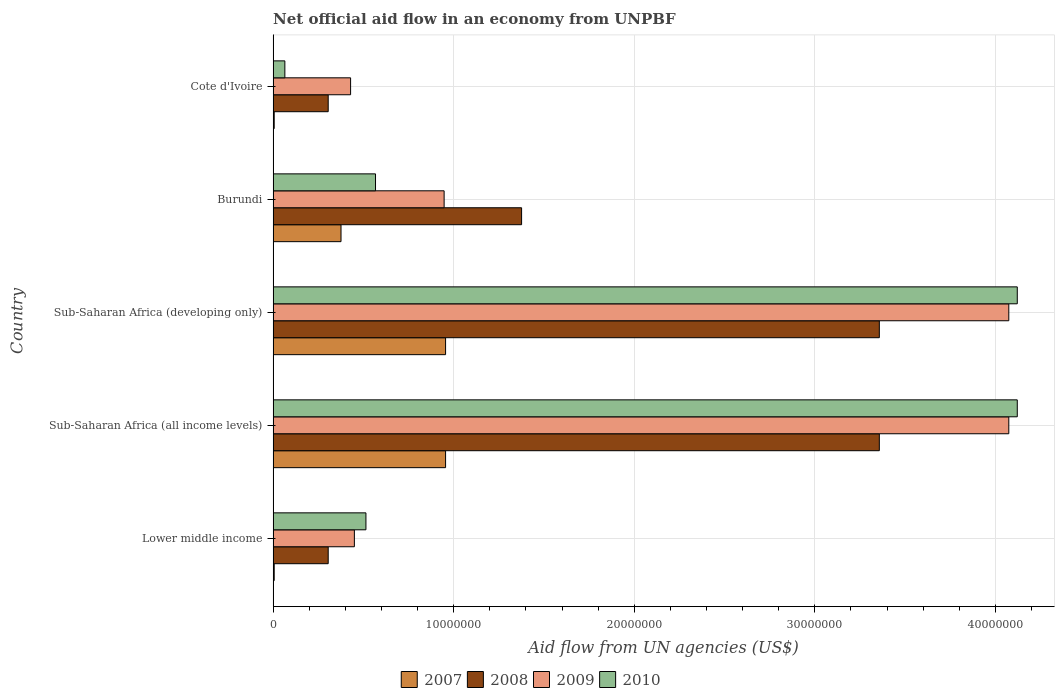How many different coloured bars are there?
Offer a very short reply. 4. How many bars are there on the 2nd tick from the bottom?
Keep it short and to the point. 4. What is the label of the 5th group of bars from the top?
Give a very brief answer. Lower middle income. What is the net official aid flow in 2009 in Sub-Saharan Africa (all income levels)?
Provide a succinct answer. 4.07e+07. Across all countries, what is the maximum net official aid flow in 2009?
Offer a terse response. 4.07e+07. Across all countries, what is the minimum net official aid flow in 2008?
Give a very brief answer. 3.05e+06. In which country was the net official aid flow in 2008 maximum?
Keep it short and to the point. Sub-Saharan Africa (all income levels). In which country was the net official aid flow in 2009 minimum?
Ensure brevity in your answer.  Cote d'Ivoire. What is the total net official aid flow in 2007 in the graph?
Your answer should be very brief. 2.30e+07. What is the difference between the net official aid flow in 2007 in Burundi and that in Cote d'Ivoire?
Make the answer very short. 3.70e+06. What is the difference between the net official aid flow in 2009 in Burundi and the net official aid flow in 2008 in Sub-Saharan Africa (developing only)?
Ensure brevity in your answer.  -2.41e+07. What is the average net official aid flow in 2010 per country?
Give a very brief answer. 1.88e+07. What is the difference between the net official aid flow in 2007 and net official aid flow in 2010 in Cote d'Ivoire?
Provide a succinct answer. -5.90e+05. In how many countries, is the net official aid flow in 2010 greater than 24000000 US$?
Make the answer very short. 2. What is the ratio of the net official aid flow in 2009 in Lower middle income to that in Sub-Saharan Africa (all income levels)?
Ensure brevity in your answer.  0.11. Is the net official aid flow in 2008 in Burundi less than that in Sub-Saharan Africa (all income levels)?
Offer a very short reply. Yes. Is the difference between the net official aid flow in 2007 in Burundi and Lower middle income greater than the difference between the net official aid flow in 2010 in Burundi and Lower middle income?
Your response must be concise. Yes. What is the difference between the highest and the second highest net official aid flow in 2010?
Make the answer very short. 0. What is the difference between the highest and the lowest net official aid flow in 2010?
Your response must be concise. 4.06e+07. Is the sum of the net official aid flow in 2009 in Burundi and Sub-Saharan Africa (developing only) greater than the maximum net official aid flow in 2008 across all countries?
Give a very brief answer. Yes. Is it the case that in every country, the sum of the net official aid flow in 2007 and net official aid flow in 2010 is greater than the net official aid flow in 2009?
Your response must be concise. No. How many bars are there?
Offer a terse response. 20. Are all the bars in the graph horizontal?
Your answer should be very brief. Yes. Are the values on the major ticks of X-axis written in scientific E-notation?
Provide a short and direct response. No. Does the graph contain any zero values?
Provide a succinct answer. No. Does the graph contain grids?
Your response must be concise. Yes. Where does the legend appear in the graph?
Your answer should be compact. Bottom center. How many legend labels are there?
Offer a very short reply. 4. How are the legend labels stacked?
Make the answer very short. Horizontal. What is the title of the graph?
Your response must be concise. Net official aid flow in an economy from UNPBF. Does "1976" appear as one of the legend labels in the graph?
Offer a very short reply. No. What is the label or title of the X-axis?
Ensure brevity in your answer.  Aid flow from UN agencies (US$). What is the Aid flow from UN agencies (US$) of 2007 in Lower middle income?
Ensure brevity in your answer.  6.00e+04. What is the Aid flow from UN agencies (US$) of 2008 in Lower middle income?
Give a very brief answer. 3.05e+06. What is the Aid flow from UN agencies (US$) in 2009 in Lower middle income?
Your answer should be very brief. 4.50e+06. What is the Aid flow from UN agencies (US$) in 2010 in Lower middle income?
Your answer should be compact. 5.14e+06. What is the Aid flow from UN agencies (US$) of 2007 in Sub-Saharan Africa (all income levels)?
Your answer should be compact. 9.55e+06. What is the Aid flow from UN agencies (US$) of 2008 in Sub-Saharan Africa (all income levels)?
Provide a succinct answer. 3.36e+07. What is the Aid flow from UN agencies (US$) of 2009 in Sub-Saharan Africa (all income levels)?
Keep it short and to the point. 4.07e+07. What is the Aid flow from UN agencies (US$) in 2010 in Sub-Saharan Africa (all income levels)?
Provide a succinct answer. 4.12e+07. What is the Aid flow from UN agencies (US$) in 2007 in Sub-Saharan Africa (developing only)?
Your answer should be compact. 9.55e+06. What is the Aid flow from UN agencies (US$) of 2008 in Sub-Saharan Africa (developing only)?
Your answer should be very brief. 3.36e+07. What is the Aid flow from UN agencies (US$) of 2009 in Sub-Saharan Africa (developing only)?
Provide a succinct answer. 4.07e+07. What is the Aid flow from UN agencies (US$) in 2010 in Sub-Saharan Africa (developing only)?
Your response must be concise. 4.12e+07. What is the Aid flow from UN agencies (US$) in 2007 in Burundi?
Your response must be concise. 3.76e+06. What is the Aid flow from UN agencies (US$) of 2008 in Burundi?
Keep it short and to the point. 1.38e+07. What is the Aid flow from UN agencies (US$) of 2009 in Burundi?
Your answer should be compact. 9.47e+06. What is the Aid flow from UN agencies (US$) of 2010 in Burundi?
Give a very brief answer. 5.67e+06. What is the Aid flow from UN agencies (US$) in 2007 in Cote d'Ivoire?
Make the answer very short. 6.00e+04. What is the Aid flow from UN agencies (US$) in 2008 in Cote d'Ivoire?
Offer a terse response. 3.05e+06. What is the Aid flow from UN agencies (US$) of 2009 in Cote d'Ivoire?
Ensure brevity in your answer.  4.29e+06. What is the Aid flow from UN agencies (US$) in 2010 in Cote d'Ivoire?
Make the answer very short. 6.50e+05. Across all countries, what is the maximum Aid flow from UN agencies (US$) in 2007?
Offer a very short reply. 9.55e+06. Across all countries, what is the maximum Aid flow from UN agencies (US$) of 2008?
Offer a terse response. 3.36e+07. Across all countries, what is the maximum Aid flow from UN agencies (US$) of 2009?
Ensure brevity in your answer.  4.07e+07. Across all countries, what is the maximum Aid flow from UN agencies (US$) of 2010?
Provide a short and direct response. 4.12e+07. Across all countries, what is the minimum Aid flow from UN agencies (US$) in 2008?
Your response must be concise. 3.05e+06. Across all countries, what is the minimum Aid flow from UN agencies (US$) in 2009?
Provide a succinct answer. 4.29e+06. Across all countries, what is the minimum Aid flow from UN agencies (US$) in 2010?
Your response must be concise. 6.50e+05. What is the total Aid flow from UN agencies (US$) in 2007 in the graph?
Provide a succinct answer. 2.30e+07. What is the total Aid flow from UN agencies (US$) of 2008 in the graph?
Your response must be concise. 8.70e+07. What is the total Aid flow from UN agencies (US$) of 2009 in the graph?
Provide a succinct answer. 9.97e+07. What is the total Aid flow from UN agencies (US$) of 2010 in the graph?
Your answer should be very brief. 9.39e+07. What is the difference between the Aid flow from UN agencies (US$) in 2007 in Lower middle income and that in Sub-Saharan Africa (all income levels)?
Your answer should be very brief. -9.49e+06. What is the difference between the Aid flow from UN agencies (US$) in 2008 in Lower middle income and that in Sub-Saharan Africa (all income levels)?
Give a very brief answer. -3.05e+07. What is the difference between the Aid flow from UN agencies (US$) of 2009 in Lower middle income and that in Sub-Saharan Africa (all income levels)?
Your answer should be very brief. -3.62e+07. What is the difference between the Aid flow from UN agencies (US$) of 2010 in Lower middle income and that in Sub-Saharan Africa (all income levels)?
Make the answer very short. -3.61e+07. What is the difference between the Aid flow from UN agencies (US$) of 2007 in Lower middle income and that in Sub-Saharan Africa (developing only)?
Make the answer very short. -9.49e+06. What is the difference between the Aid flow from UN agencies (US$) of 2008 in Lower middle income and that in Sub-Saharan Africa (developing only)?
Make the answer very short. -3.05e+07. What is the difference between the Aid flow from UN agencies (US$) of 2009 in Lower middle income and that in Sub-Saharan Africa (developing only)?
Offer a very short reply. -3.62e+07. What is the difference between the Aid flow from UN agencies (US$) in 2010 in Lower middle income and that in Sub-Saharan Africa (developing only)?
Make the answer very short. -3.61e+07. What is the difference between the Aid flow from UN agencies (US$) of 2007 in Lower middle income and that in Burundi?
Offer a terse response. -3.70e+06. What is the difference between the Aid flow from UN agencies (US$) of 2008 in Lower middle income and that in Burundi?
Ensure brevity in your answer.  -1.07e+07. What is the difference between the Aid flow from UN agencies (US$) in 2009 in Lower middle income and that in Burundi?
Your answer should be very brief. -4.97e+06. What is the difference between the Aid flow from UN agencies (US$) of 2010 in Lower middle income and that in Burundi?
Offer a terse response. -5.30e+05. What is the difference between the Aid flow from UN agencies (US$) of 2007 in Lower middle income and that in Cote d'Ivoire?
Your answer should be very brief. 0. What is the difference between the Aid flow from UN agencies (US$) of 2008 in Lower middle income and that in Cote d'Ivoire?
Provide a short and direct response. 0. What is the difference between the Aid flow from UN agencies (US$) in 2010 in Lower middle income and that in Cote d'Ivoire?
Give a very brief answer. 4.49e+06. What is the difference between the Aid flow from UN agencies (US$) in 2008 in Sub-Saharan Africa (all income levels) and that in Sub-Saharan Africa (developing only)?
Your answer should be compact. 0. What is the difference between the Aid flow from UN agencies (US$) in 2010 in Sub-Saharan Africa (all income levels) and that in Sub-Saharan Africa (developing only)?
Your answer should be very brief. 0. What is the difference between the Aid flow from UN agencies (US$) of 2007 in Sub-Saharan Africa (all income levels) and that in Burundi?
Give a very brief answer. 5.79e+06. What is the difference between the Aid flow from UN agencies (US$) in 2008 in Sub-Saharan Africa (all income levels) and that in Burundi?
Give a very brief answer. 1.98e+07. What is the difference between the Aid flow from UN agencies (US$) of 2009 in Sub-Saharan Africa (all income levels) and that in Burundi?
Your answer should be compact. 3.13e+07. What is the difference between the Aid flow from UN agencies (US$) of 2010 in Sub-Saharan Africa (all income levels) and that in Burundi?
Provide a succinct answer. 3.55e+07. What is the difference between the Aid flow from UN agencies (US$) of 2007 in Sub-Saharan Africa (all income levels) and that in Cote d'Ivoire?
Offer a very short reply. 9.49e+06. What is the difference between the Aid flow from UN agencies (US$) of 2008 in Sub-Saharan Africa (all income levels) and that in Cote d'Ivoire?
Make the answer very short. 3.05e+07. What is the difference between the Aid flow from UN agencies (US$) of 2009 in Sub-Saharan Africa (all income levels) and that in Cote d'Ivoire?
Your response must be concise. 3.64e+07. What is the difference between the Aid flow from UN agencies (US$) of 2010 in Sub-Saharan Africa (all income levels) and that in Cote d'Ivoire?
Provide a succinct answer. 4.06e+07. What is the difference between the Aid flow from UN agencies (US$) of 2007 in Sub-Saharan Africa (developing only) and that in Burundi?
Ensure brevity in your answer.  5.79e+06. What is the difference between the Aid flow from UN agencies (US$) in 2008 in Sub-Saharan Africa (developing only) and that in Burundi?
Make the answer very short. 1.98e+07. What is the difference between the Aid flow from UN agencies (US$) of 2009 in Sub-Saharan Africa (developing only) and that in Burundi?
Provide a short and direct response. 3.13e+07. What is the difference between the Aid flow from UN agencies (US$) of 2010 in Sub-Saharan Africa (developing only) and that in Burundi?
Your answer should be very brief. 3.55e+07. What is the difference between the Aid flow from UN agencies (US$) of 2007 in Sub-Saharan Africa (developing only) and that in Cote d'Ivoire?
Keep it short and to the point. 9.49e+06. What is the difference between the Aid flow from UN agencies (US$) of 2008 in Sub-Saharan Africa (developing only) and that in Cote d'Ivoire?
Offer a very short reply. 3.05e+07. What is the difference between the Aid flow from UN agencies (US$) of 2009 in Sub-Saharan Africa (developing only) and that in Cote d'Ivoire?
Offer a very short reply. 3.64e+07. What is the difference between the Aid flow from UN agencies (US$) of 2010 in Sub-Saharan Africa (developing only) and that in Cote d'Ivoire?
Your answer should be very brief. 4.06e+07. What is the difference between the Aid flow from UN agencies (US$) in 2007 in Burundi and that in Cote d'Ivoire?
Your response must be concise. 3.70e+06. What is the difference between the Aid flow from UN agencies (US$) of 2008 in Burundi and that in Cote d'Ivoire?
Provide a succinct answer. 1.07e+07. What is the difference between the Aid flow from UN agencies (US$) of 2009 in Burundi and that in Cote d'Ivoire?
Keep it short and to the point. 5.18e+06. What is the difference between the Aid flow from UN agencies (US$) in 2010 in Burundi and that in Cote d'Ivoire?
Keep it short and to the point. 5.02e+06. What is the difference between the Aid flow from UN agencies (US$) of 2007 in Lower middle income and the Aid flow from UN agencies (US$) of 2008 in Sub-Saharan Africa (all income levels)?
Provide a succinct answer. -3.35e+07. What is the difference between the Aid flow from UN agencies (US$) of 2007 in Lower middle income and the Aid flow from UN agencies (US$) of 2009 in Sub-Saharan Africa (all income levels)?
Your response must be concise. -4.07e+07. What is the difference between the Aid flow from UN agencies (US$) in 2007 in Lower middle income and the Aid flow from UN agencies (US$) in 2010 in Sub-Saharan Africa (all income levels)?
Give a very brief answer. -4.12e+07. What is the difference between the Aid flow from UN agencies (US$) in 2008 in Lower middle income and the Aid flow from UN agencies (US$) in 2009 in Sub-Saharan Africa (all income levels)?
Provide a succinct answer. -3.77e+07. What is the difference between the Aid flow from UN agencies (US$) in 2008 in Lower middle income and the Aid flow from UN agencies (US$) in 2010 in Sub-Saharan Africa (all income levels)?
Make the answer very short. -3.82e+07. What is the difference between the Aid flow from UN agencies (US$) in 2009 in Lower middle income and the Aid flow from UN agencies (US$) in 2010 in Sub-Saharan Africa (all income levels)?
Your response must be concise. -3.67e+07. What is the difference between the Aid flow from UN agencies (US$) of 2007 in Lower middle income and the Aid flow from UN agencies (US$) of 2008 in Sub-Saharan Africa (developing only)?
Provide a succinct answer. -3.35e+07. What is the difference between the Aid flow from UN agencies (US$) of 2007 in Lower middle income and the Aid flow from UN agencies (US$) of 2009 in Sub-Saharan Africa (developing only)?
Keep it short and to the point. -4.07e+07. What is the difference between the Aid flow from UN agencies (US$) of 2007 in Lower middle income and the Aid flow from UN agencies (US$) of 2010 in Sub-Saharan Africa (developing only)?
Offer a terse response. -4.12e+07. What is the difference between the Aid flow from UN agencies (US$) in 2008 in Lower middle income and the Aid flow from UN agencies (US$) in 2009 in Sub-Saharan Africa (developing only)?
Your answer should be very brief. -3.77e+07. What is the difference between the Aid flow from UN agencies (US$) in 2008 in Lower middle income and the Aid flow from UN agencies (US$) in 2010 in Sub-Saharan Africa (developing only)?
Make the answer very short. -3.82e+07. What is the difference between the Aid flow from UN agencies (US$) in 2009 in Lower middle income and the Aid flow from UN agencies (US$) in 2010 in Sub-Saharan Africa (developing only)?
Your response must be concise. -3.67e+07. What is the difference between the Aid flow from UN agencies (US$) in 2007 in Lower middle income and the Aid flow from UN agencies (US$) in 2008 in Burundi?
Provide a succinct answer. -1.37e+07. What is the difference between the Aid flow from UN agencies (US$) in 2007 in Lower middle income and the Aid flow from UN agencies (US$) in 2009 in Burundi?
Your response must be concise. -9.41e+06. What is the difference between the Aid flow from UN agencies (US$) in 2007 in Lower middle income and the Aid flow from UN agencies (US$) in 2010 in Burundi?
Your response must be concise. -5.61e+06. What is the difference between the Aid flow from UN agencies (US$) of 2008 in Lower middle income and the Aid flow from UN agencies (US$) of 2009 in Burundi?
Offer a terse response. -6.42e+06. What is the difference between the Aid flow from UN agencies (US$) in 2008 in Lower middle income and the Aid flow from UN agencies (US$) in 2010 in Burundi?
Offer a very short reply. -2.62e+06. What is the difference between the Aid flow from UN agencies (US$) of 2009 in Lower middle income and the Aid flow from UN agencies (US$) of 2010 in Burundi?
Keep it short and to the point. -1.17e+06. What is the difference between the Aid flow from UN agencies (US$) in 2007 in Lower middle income and the Aid flow from UN agencies (US$) in 2008 in Cote d'Ivoire?
Provide a succinct answer. -2.99e+06. What is the difference between the Aid flow from UN agencies (US$) in 2007 in Lower middle income and the Aid flow from UN agencies (US$) in 2009 in Cote d'Ivoire?
Offer a terse response. -4.23e+06. What is the difference between the Aid flow from UN agencies (US$) of 2007 in Lower middle income and the Aid flow from UN agencies (US$) of 2010 in Cote d'Ivoire?
Give a very brief answer. -5.90e+05. What is the difference between the Aid flow from UN agencies (US$) in 2008 in Lower middle income and the Aid flow from UN agencies (US$) in 2009 in Cote d'Ivoire?
Provide a succinct answer. -1.24e+06. What is the difference between the Aid flow from UN agencies (US$) of 2008 in Lower middle income and the Aid flow from UN agencies (US$) of 2010 in Cote d'Ivoire?
Provide a succinct answer. 2.40e+06. What is the difference between the Aid flow from UN agencies (US$) in 2009 in Lower middle income and the Aid flow from UN agencies (US$) in 2010 in Cote d'Ivoire?
Make the answer very short. 3.85e+06. What is the difference between the Aid flow from UN agencies (US$) in 2007 in Sub-Saharan Africa (all income levels) and the Aid flow from UN agencies (US$) in 2008 in Sub-Saharan Africa (developing only)?
Your answer should be compact. -2.40e+07. What is the difference between the Aid flow from UN agencies (US$) in 2007 in Sub-Saharan Africa (all income levels) and the Aid flow from UN agencies (US$) in 2009 in Sub-Saharan Africa (developing only)?
Give a very brief answer. -3.12e+07. What is the difference between the Aid flow from UN agencies (US$) in 2007 in Sub-Saharan Africa (all income levels) and the Aid flow from UN agencies (US$) in 2010 in Sub-Saharan Africa (developing only)?
Ensure brevity in your answer.  -3.17e+07. What is the difference between the Aid flow from UN agencies (US$) of 2008 in Sub-Saharan Africa (all income levels) and the Aid flow from UN agencies (US$) of 2009 in Sub-Saharan Africa (developing only)?
Provide a short and direct response. -7.17e+06. What is the difference between the Aid flow from UN agencies (US$) in 2008 in Sub-Saharan Africa (all income levels) and the Aid flow from UN agencies (US$) in 2010 in Sub-Saharan Africa (developing only)?
Keep it short and to the point. -7.64e+06. What is the difference between the Aid flow from UN agencies (US$) in 2009 in Sub-Saharan Africa (all income levels) and the Aid flow from UN agencies (US$) in 2010 in Sub-Saharan Africa (developing only)?
Offer a terse response. -4.70e+05. What is the difference between the Aid flow from UN agencies (US$) of 2007 in Sub-Saharan Africa (all income levels) and the Aid flow from UN agencies (US$) of 2008 in Burundi?
Your answer should be very brief. -4.21e+06. What is the difference between the Aid flow from UN agencies (US$) of 2007 in Sub-Saharan Africa (all income levels) and the Aid flow from UN agencies (US$) of 2010 in Burundi?
Provide a short and direct response. 3.88e+06. What is the difference between the Aid flow from UN agencies (US$) of 2008 in Sub-Saharan Africa (all income levels) and the Aid flow from UN agencies (US$) of 2009 in Burundi?
Provide a succinct answer. 2.41e+07. What is the difference between the Aid flow from UN agencies (US$) in 2008 in Sub-Saharan Africa (all income levels) and the Aid flow from UN agencies (US$) in 2010 in Burundi?
Give a very brief answer. 2.79e+07. What is the difference between the Aid flow from UN agencies (US$) in 2009 in Sub-Saharan Africa (all income levels) and the Aid flow from UN agencies (US$) in 2010 in Burundi?
Make the answer very short. 3.51e+07. What is the difference between the Aid flow from UN agencies (US$) of 2007 in Sub-Saharan Africa (all income levels) and the Aid flow from UN agencies (US$) of 2008 in Cote d'Ivoire?
Make the answer very short. 6.50e+06. What is the difference between the Aid flow from UN agencies (US$) in 2007 in Sub-Saharan Africa (all income levels) and the Aid flow from UN agencies (US$) in 2009 in Cote d'Ivoire?
Provide a short and direct response. 5.26e+06. What is the difference between the Aid flow from UN agencies (US$) of 2007 in Sub-Saharan Africa (all income levels) and the Aid flow from UN agencies (US$) of 2010 in Cote d'Ivoire?
Make the answer very short. 8.90e+06. What is the difference between the Aid flow from UN agencies (US$) of 2008 in Sub-Saharan Africa (all income levels) and the Aid flow from UN agencies (US$) of 2009 in Cote d'Ivoire?
Your answer should be very brief. 2.93e+07. What is the difference between the Aid flow from UN agencies (US$) of 2008 in Sub-Saharan Africa (all income levels) and the Aid flow from UN agencies (US$) of 2010 in Cote d'Ivoire?
Your response must be concise. 3.29e+07. What is the difference between the Aid flow from UN agencies (US$) of 2009 in Sub-Saharan Africa (all income levels) and the Aid flow from UN agencies (US$) of 2010 in Cote d'Ivoire?
Provide a succinct answer. 4.01e+07. What is the difference between the Aid flow from UN agencies (US$) in 2007 in Sub-Saharan Africa (developing only) and the Aid flow from UN agencies (US$) in 2008 in Burundi?
Keep it short and to the point. -4.21e+06. What is the difference between the Aid flow from UN agencies (US$) in 2007 in Sub-Saharan Africa (developing only) and the Aid flow from UN agencies (US$) in 2009 in Burundi?
Keep it short and to the point. 8.00e+04. What is the difference between the Aid flow from UN agencies (US$) of 2007 in Sub-Saharan Africa (developing only) and the Aid flow from UN agencies (US$) of 2010 in Burundi?
Provide a succinct answer. 3.88e+06. What is the difference between the Aid flow from UN agencies (US$) in 2008 in Sub-Saharan Africa (developing only) and the Aid flow from UN agencies (US$) in 2009 in Burundi?
Provide a short and direct response. 2.41e+07. What is the difference between the Aid flow from UN agencies (US$) of 2008 in Sub-Saharan Africa (developing only) and the Aid flow from UN agencies (US$) of 2010 in Burundi?
Keep it short and to the point. 2.79e+07. What is the difference between the Aid flow from UN agencies (US$) of 2009 in Sub-Saharan Africa (developing only) and the Aid flow from UN agencies (US$) of 2010 in Burundi?
Ensure brevity in your answer.  3.51e+07. What is the difference between the Aid flow from UN agencies (US$) of 2007 in Sub-Saharan Africa (developing only) and the Aid flow from UN agencies (US$) of 2008 in Cote d'Ivoire?
Your answer should be very brief. 6.50e+06. What is the difference between the Aid flow from UN agencies (US$) in 2007 in Sub-Saharan Africa (developing only) and the Aid flow from UN agencies (US$) in 2009 in Cote d'Ivoire?
Provide a succinct answer. 5.26e+06. What is the difference between the Aid flow from UN agencies (US$) of 2007 in Sub-Saharan Africa (developing only) and the Aid flow from UN agencies (US$) of 2010 in Cote d'Ivoire?
Make the answer very short. 8.90e+06. What is the difference between the Aid flow from UN agencies (US$) of 2008 in Sub-Saharan Africa (developing only) and the Aid flow from UN agencies (US$) of 2009 in Cote d'Ivoire?
Your response must be concise. 2.93e+07. What is the difference between the Aid flow from UN agencies (US$) of 2008 in Sub-Saharan Africa (developing only) and the Aid flow from UN agencies (US$) of 2010 in Cote d'Ivoire?
Provide a short and direct response. 3.29e+07. What is the difference between the Aid flow from UN agencies (US$) in 2009 in Sub-Saharan Africa (developing only) and the Aid flow from UN agencies (US$) in 2010 in Cote d'Ivoire?
Give a very brief answer. 4.01e+07. What is the difference between the Aid flow from UN agencies (US$) of 2007 in Burundi and the Aid flow from UN agencies (US$) of 2008 in Cote d'Ivoire?
Give a very brief answer. 7.10e+05. What is the difference between the Aid flow from UN agencies (US$) in 2007 in Burundi and the Aid flow from UN agencies (US$) in 2009 in Cote d'Ivoire?
Your answer should be compact. -5.30e+05. What is the difference between the Aid flow from UN agencies (US$) in 2007 in Burundi and the Aid flow from UN agencies (US$) in 2010 in Cote d'Ivoire?
Your answer should be compact. 3.11e+06. What is the difference between the Aid flow from UN agencies (US$) in 2008 in Burundi and the Aid flow from UN agencies (US$) in 2009 in Cote d'Ivoire?
Provide a short and direct response. 9.47e+06. What is the difference between the Aid flow from UN agencies (US$) of 2008 in Burundi and the Aid flow from UN agencies (US$) of 2010 in Cote d'Ivoire?
Provide a short and direct response. 1.31e+07. What is the difference between the Aid flow from UN agencies (US$) of 2009 in Burundi and the Aid flow from UN agencies (US$) of 2010 in Cote d'Ivoire?
Ensure brevity in your answer.  8.82e+06. What is the average Aid flow from UN agencies (US$) of 2007 per country?
Keep it short and to the point. 4.60e+06. What is the average Aid flow from UN agencies (US$) of 2008 per country?
Your answer should be very brief. 1.74e+07. What is the average Aid flow from UN agencies (US$) of 2009 per country?
Provide a succinct answer. 1.99e+07. What is the average Aid flow from UN agencies (US$) in 2010 per country?
Your answer should be very brief. 1.88e+07. What is the difference between the Aid flow from UN agencies (US$) in 2007 and Aid flow from UN agencies (US$) in 2008 in Lower middle income?
Keep it short and to the point. -2.99e+06. What is the difference between the Aid flow from UN agencies (US$) of 2007 and Aid flow from UN agencies (US$) of 2009 in Lower middle income?
Offer a very short reply. -4.44e+06. What is the difference between the Aid flow from UN agencies (US$) of 2007 and Aid flow from UN agencies (US$) of 2010 in Lower middle income?
Ensure brevity in your answer.  -5.08e+06. What is the difference between the Aid flow from UN agencies (US$) of 2008 and Aid flow from UN agencies (US$) of 2009 in Lower middle income?
Make the answer very short. -1.45e+06. What is the difference between the Aid flow from UN agencies (US$) in 2008 and Aid flow from UN agencies (US$) in 2010 in Lower middle income?
Offer a very short reply. -2.09e+06. What is the difference between the Aid flow from UN agencies (US$) in 2009 and Aid flow from UN agencies (US$) in 2010 in Lower middle income?
Ensure brevity in your answer.  -6.40e+05. What is the difference between the Aid flow from UN agencies (US$) of 2007 and Aid flow from UN agencies (US$) of 2008 in Sub-Saharan Africa (all income levels)?
Give a very brief answer. -2.40e+07. What is the difference between the Aid flow from UN agencies (US$) of 2007 and Aid flow from UN agencies (US$) of 2009 in Sub-Saharan Africa (all income levels)?
Your response must be concise. -3.12e+07. What is the difference between the Aid flow from UN agencies (US$) in 2007 and Aid flow from UN agencies (US$) in 2010 in Sub-Saharan Africa (all income levels)?
Make the answer very short. -3.17e+07. What is the difference between the Aid flow from UN agencies (US$) of 2008 and Aid flow from UN agencies (US$) of 2009 in Sub-Saharan Africa (all income levels)?
Your answer should be compact. -7.17e+06. What is the difference between the Aid flow from UN agencies (US$) of 2008 and Aid flow from UN agencies (US$) of 2010 in Sub-Saharan Africa (all income levels)?
Ensure brevity in your answer.  -7.64e+06. What is the difference between the Aid flow from UN agencies (US$) of 2009 and Aid flow from UN agencies (US$) of 2010 in Sub-Saharan Africa (all income levels)?
Make the answer very short. -4.70e+05. What is the difference between the Aid flow from UN agencies (US$) in 2007 and Aid flow from UN agencies (US$) in 2008 in Sub-Saharan Africa (developing only)?
Offer a very short reply. -2.40e+07. What is the difference between the Aid flow from UN agencies (US$) of 2007 and Aid flow from UN agencies (US$) of 2009 in Sub-Saharan Africa (developing only)?
Offer a terse response. -3.12e+07. What is the difference between the Aid flow from UN agencies (US$) of 2007 and Aid flow from UN agencies (US$) of 2010 in Sub-Saharan Africa (developing only)?
Ensure brevity in your answer.  -3.17e+07. What is the difference between the Aid flow from UN agencies (US$) of 2008 and Aid flow from UN agencies (US$) of 2009 in Sub-Saharan Africa (developing only)?
Make the answer very short. -7.17e+06. What is the difference between the Aid flow from UN agencies (US$) in 2008 and Aid flow from UN agencies (US$) in 2010 in Sub-Saharan Africa (developing only)?
Your answer should be very brief. -7.64e+06. What is the difference between the Aid flow from UN agencies (US$) in 2009 and Aid flow from UN agencies (US$) in 2010 in Sub-Saharan Africa (developing only)?
Offer a very short reply. -4.70e+05. What is the difference between the Aid flow from UN agencies (US$) of 2007 and Aid flow from UN agencies (US$) of 2008 in Burundi?
Offer a very short reply. -1.00e+07. What is the difference between the Aid flow from UN agencies (US$) in 2007 and Aid flow from UN agencies (US$) in 2009 in Burundi?
Your response must be concise. -5.71e+06. What is the difference between the Aid flow from UN agencies (US$) in 2007 and Aid flow from UN agencies (US$) in 2010 in Burundi?
Provide a succinct answer. -1.91e+06. What is the difference between the Aid flow from UN agencies (US$) in 2008 and Aid flow from UN agencies (US$) in 2009 in Burundi?
Make the answer very short. 4.29e+06. What is the difference between the Aid flow from UN agencies (US$) in 2008 and Aid flow from UN agencies (US$) in 2010 in Burundi?
Your response must be concise. 8.09e+06. What is the difference between the Aid flow from UN agencies (US$) of 2009 and Aid flow from UN agencies (US$) of 2010 in Burundi?
Give a very brief answer. 3.80e+06. What is the difference between the Aid flow from UN agencies (US$) of 2007 and Aid flow from UN agencies (US$) of 2008 in Cote d'Ivoire?
Give a very brief answer. -2.99e+06. What is the difference between the Aid flow from UN agencies (US$) of 2007 and Aid flow from UN agencies (US$) of 2009 in Cote d'Ivoire?
Ensure brevity in your answer.  -4.23e+06. What is the difference between the Aid flow from UN agencies (US$) in 2007 and Aid flow from UN agencies (US$) in 2010 in Cote d'Ivoire?
Provide a short and direct response. -5.90e+05. What is the difference between the Aid flow from UN agencies (US$) of 2008 and Aid flow from UN agencies (US$) of 2009 in Cote d'Ivoire?
Your answer should be compact. -1.24e+06. What is the difference between the Aid flow from UN agencies (US$) in 2008 and Aid flow from UN agencies (US$) in 2010 in Cote d'Ivoire?
Keep it short and to the point. 2.40e+06. What is the difference between the Aid flow from UN agencies (US$) in 2009 and Aid flow from UN agencies (US$) in 2010 in Cote d'Ivoire?
Your answer should be very brief. 3.64e+06. What is the ratio of the Aid flow from UN agencies (US$) in 2007 in Lower middle income to that in Sub-Saharan Africa (all income levels)?
Provide a short and direct response. 0.01. What is the ratio of the Aid flow from UN agencies (US$) of 2008 in Lower middle income to that in Sub-Saharan Africa (all income levels)?
Provide a succinct answer. 0.09. What is the ratio of the Aid flow from UN agencies (US$) in 2009 in Lower middle income to that in Sub-Saharan Africa (all income levels)?
Provide a short and direct response. 0.11. What is the ratio of the Aid flow from UN agencies (US$) in 2010 in Lower middle income to that in Sub-Saharan Africa (all income levels)?
Give a very brief answer. 0.12. What is the ratio of the Aid flow from UN agencies (US$) of 2007 in Lower middle income to that in Sub-Saharan Africa (developing only)?
Provide a succinct answer. 0.01. What is the ratio of the Aid flow from UN agencies (US$) of 2008 in Lower middle income to that in Sub-Saharan Africa (developing only)?
Your answer should be compact. 0.09. What is the ratio of the Aid flow from UN agencies (US$) in 2009 in Lower middle income to that in Sub-Saharan Africa (developing only)?
Your answer should be very brief. 0.11. What is the ratio of the Aid flow from UN agencies (US$) in 2010 in Lower middle income to that in Sub-Saharan Africa (developing only)?
Keep it short and to the point. 0.12. What is the ratio of the Aid flow from UN agencies (US$) in 2007 in Lower middle income to that in Burundi?
Offer a very short reply. 0.02. What is the ratio of the Aid flow from UN agencies (US$) in 2008 in Lower middle income to that in Burundi?
Your answer should be compact. 0.22. What is the ratio of the Aid flow from UN agencies (US$) of 2009 in Lower middle income to that in Burundi?
Provide a short and direct response. 0.48. What is the ratio of the Aid flow from UN agencies (US$) of 2010 in Lower middle income to that in Burundi?
Give a very brief answer. 0.91. What is the ratio of the Aid flow from UN agencies (US$) of 2007 in Lower middle income to that in Cote d'Ivoire?
Offer a terse response. 1. What is the ratio of the Aid flow from UN agencies (US$) in 2008 in Lower middle income to that in Cote d'Ivoire?
Give a very brief answer. 1. What is the ratio of the Aid flow from UN agencies (US$) in 2009 in Lower middle income to that in Cote d'Ivoire?
Make the answer very short. 1.05. What is the ratio of the Aid flow from UN agencies (US$) in 2010 in Lower middle income to that in Cote d'Ivoire?
Provide a succinct answer. 7.91. What is the ratio of the Aid flow from UN agencies (US$) of 2007 in Sub-Saharan Africa (all income levels) to that in Sub-Saharan Africa (developing only)?
Offer a terse response. 1. What is the ratio of the Aid flow from UN agencies (US$) of 2007 in Sub-Saharan Africa (all income levels) to that in Burundi?
Offer a very short reply. 2.54. What is the ratio of the Aid flow from UN agencies (US$) in 2008 in Sub-Saharan Africa (all income levels) to that in Burundi?
Your answer should be compact. 2.44. What is the ratio of the Aid flow from UN agencies (US$) in 2009 in Sub-Saharan Africa (all income levels) to that in Burundi?
Give a very brief answer. 4.3. What is the ratio of the Aid flow from UN agencies (US$) in 2010 in Sub-Saharan Africa (all income levels) to that in Burundi?
Offer a very short reply. 7.27. What is the ratio of the Aid flow from UN agencies (US$) in 2007 in Sub-Saharan Africa (all income levels) to that in Cote d'Ivoire?
Ensure brevity in your answer.  159.17. What is the ratio of the Aid flow from UN agencies (US$) of 2008 in Sub-Saharan Africa (all income levels) to that in Cote d'Ivoire?
Ensure brevity in your answer.  11.01. What is the ratio of the Aid flow from UN agencies (US$) in 2009 in Sub-Saharan Africa (all income levels) to that in Cote d'Ivoire?
Ensure brevity in your answer.  9.5. What is the ratio of the Aid flow from UN agencies (US$) in 2010 in Sub-Saharan Africa (all income levels) to that in Cote d'Ivoire?
Your response must be concise. 63.4. What is the ratio of the Aid flow from UN agencies (US$) in 2007 in Sub-Saharan Africa (developing only) to that in Burundi?
Offer a very short reply. 2.54. What is the ratio of the Aid flow from UN agencies (US$) in 2008 in Sub-Saharan Africa (developing only) to that in Burundi?
Make the answer very short. 2.44. What is the ratio of the Aid flow from UN agencies (US$) in 2009 in Sub-Saharan Africa (developing only) to that in Burundi?
Your answer should be very brief. 4.3. What is the ratio of the Aid flow from UN agencies (US$) of 2010 in Sub-Saharan Africa (developing only) to that in Burundi?
Your answer should be compact. 7.27. What is the ratio of the Aid flow from UN agencies (US$) in 2007 in Sub-Saharan Africa (developing only) to that in Cote d'Ivoire?
Your answer should be very brief. 159.17. What is the ratio of the Aid flow from UN agencies (US$) in 2008 in Sub-Saharan Africa (developing only) to that in Cote d'Ivoire?
Give a very brief answer. 11.01. What is the ratio of the Aid flow from UN agencies (US$) of 2009 in Sub-Saharan Africa (developing only) to that in Cote d'Ivoire?
Offer a very short reply. 9.5. What is the ratio of the Aid flow from UN agencies (US$) in 2010 in Sub-Saharan Africa (developing only) to that in Cote d'Ivoire?
Keep it short and to the point. 63.4. What is the ratio of the Aid flow from UN agencies (US$) in 2007 in Burundi to that in Cote d'Ivoire?
Offer a very short reply. 62.67. What is the ratio of the Aid flow from UN agencies (US$) in 2008 in Burundi to that in Cote d'Ivoire?
Offer a terse response. 4.51. What is the ratio of the Aid flow from UN agencies (US$) of 2009 in Burundi to that in Cote d'Ivoire?
Your response must be concise. 2.21. What is the ratio of the Aid flow from UN agencies (US$) in 2010 in Burundi to that in Cote d'Ivoire?
Make the answer very short. 8.72. What is the difference between the highest and the second highest Aid flow from UN agencies (US$) of 2007?
Offer a very short reply. 0. What is the difference between the highest and the second highest Aid flow from UN agencies (US$) of 2008?
Ensure brevity in your answer.  0. What is the difference between the highest and the lowest Aid flow from UN agencies (US$) in 2007?
Offer a terse response. 9.49e+06. What is the difference between the highest and the lowest Aid flow from UN agencies (US$) in 2008?
Offer a very short reply. 3.05e+07. What is the difference between the highest and the lowest Aid flow from UN agencies (US$) in 2009?
Provide a short and direct response. 3.64e+07. What is the difference between the highest and the lowest Aid flow from UN agencies (US$) in 2010?
Provide a short and direct response. 4.06e+07. 